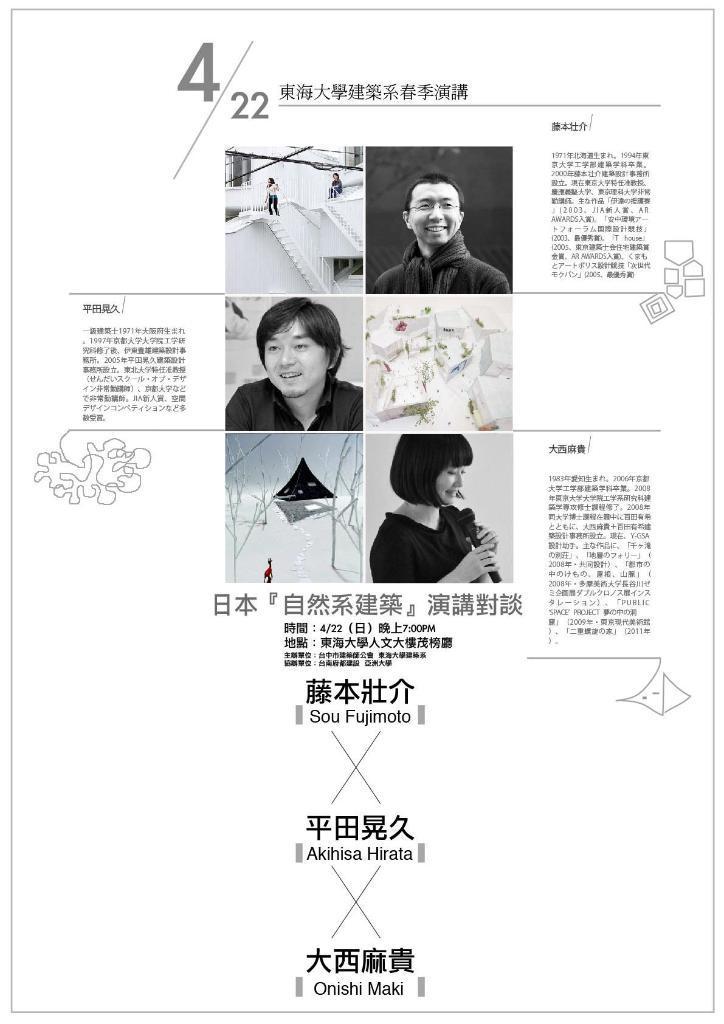Can you describe this image briefly? In this image we an see a poster, here are the images on it, here it is in black and white, here is some matter written on it. 